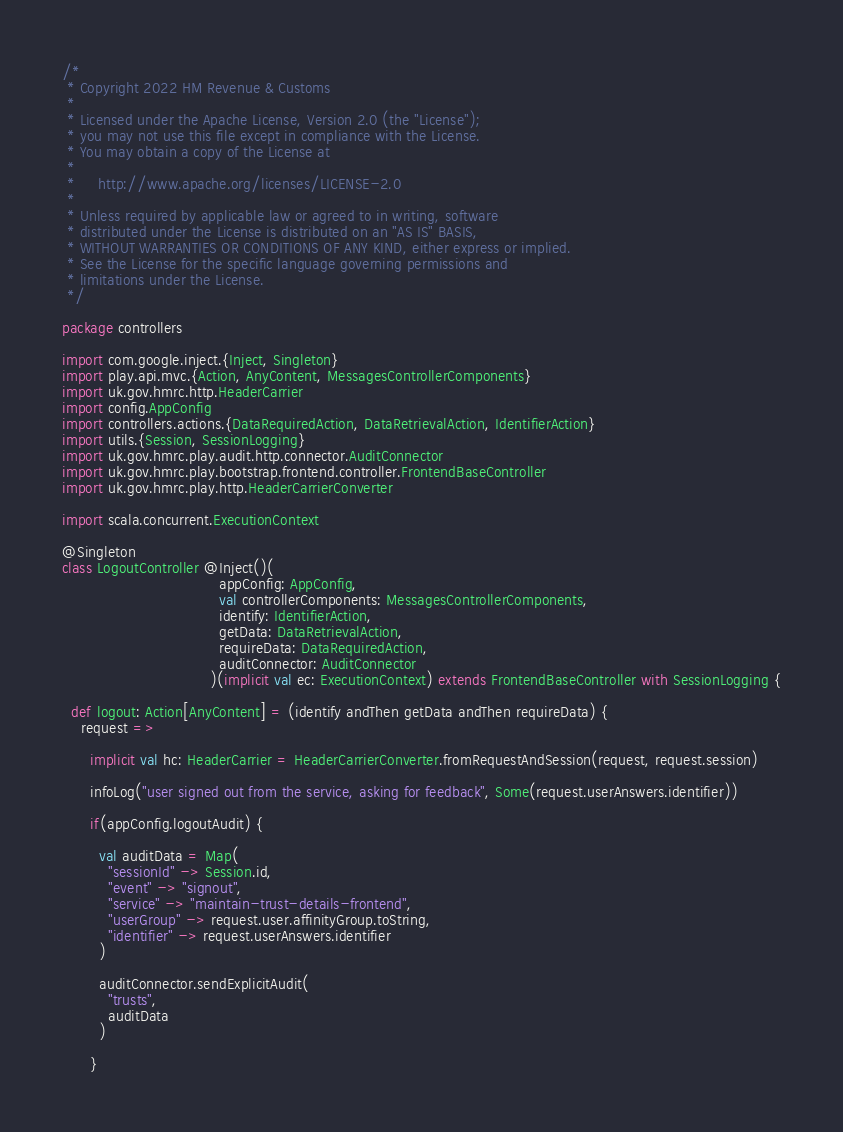Convert code to text. <code><loc_0><loc_0><loc_500><loc_500><_Scala_>/*
 * Copyright 2022 HM Revenue & Customs
 *
 * Licensed under the Apache License, Version 2.0 (the "License");
 * you may not use this file except in compliance with the License.
 * You may obtain a copy of the License at
 *
 *     http://www.apache.org/licenses/LICENSE-2.0
 *
 * Unless required by applicable law or agreed to in writing, software
 * distributed under the License is distributed on an "AS IS" BASIS,
 * WITHOUT WARRANTIES OR CONDITIONS OF ANY KIND, either express or implied.
 * See the License for the specific language governing permissions and
 * limitations under the License.
 */

package controllers

import com.google.inject.{Inject, Singleton}
import play.api.mvc.{Action, AnyContent, MessagesControllerComponents}
import uk.gov.hmrc.http.HeaderCarrier
import config.AppConfig
import controllers.actions.{DataRequiredAction, DataRetrievalAction, IdentifierAction}
import utils.{Session, SessionLogging}
import uk.gov.hmrc.play.audit.http.connector.AuditConnector
import uk.gov.hmrc.play.bootstrap.frontend.controller.FrontendBaseController
import uk.gov.hmrc.play.http.HeaderCarrierConverter

import scala.concurrent.ExecutionContext

@Singleton
class LogoutController @Inject()(
                                  appConfig: AppConfig,
                                  val controllerComponents: MessagesControllerComponents,
                                  identify: IdentifierAction,
                                  getData: DataRetrievalAction,
                                  requireData: DataRequiredAction,
                                  auditConnector: AuditConnector
                                )(implicit val ec: ExecutionContext) extends FrontendBaseController with SessionLogging {

  def logout: Action[AnyContent] = (identify andThen getData andThen requireData) {
    request =>

      implicit val hc: HeaderCarrier = HeaderCarrierConverter.fromRequestAndSession(request, request.session)

      infoLog("user signed out from the service, asking for feedback", Some(request.userAnswers.identifier))

      if(appConfig.logoutAudit) {

        val auditData = Map(
          "sessionId" -> Session.id,
          "event" -> "signout",
          "service" -> "maintain-trust-details-frontend",
          "userGroup" -> request.user.affinityGroup.toString,
          "identifier" -> request.userAnswers.identifier
        )

        auditConnector.sendExplicitAudit(
          "trusts",
          auditData
        )

      }
</code> 